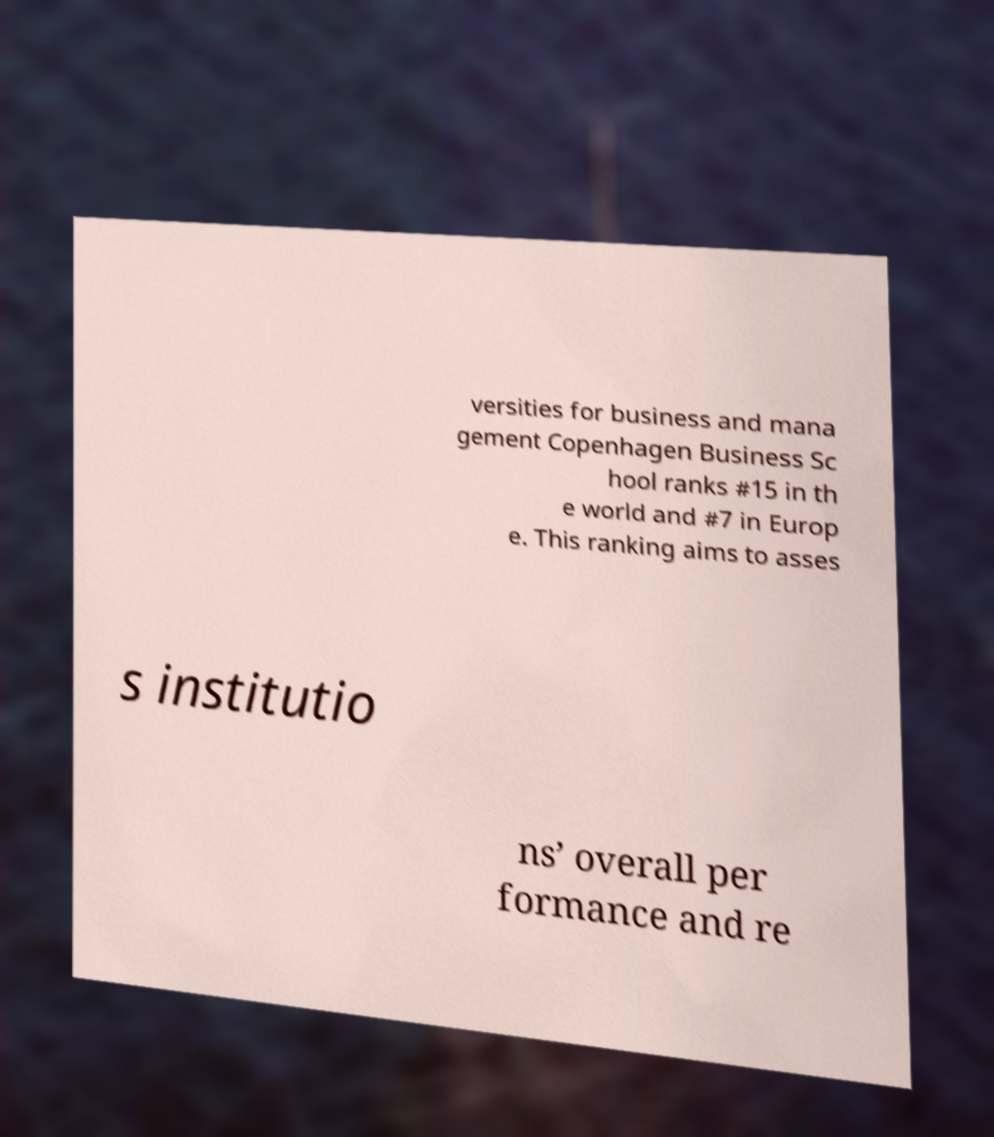Could you extract and type out the text from this image? versities for business and mana gement Copenhagen Business Sc hool ranks #15 in th e world and #7 in Europ e. This ranking aims to asses s institutio ns’ overall per formance and re 